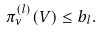<formula> <loc_0><loc_0><loc_500><loc_500>\pi ^ { ( l ) } _ { \nu } ( V ) \leq b _ { l } .</formula> 